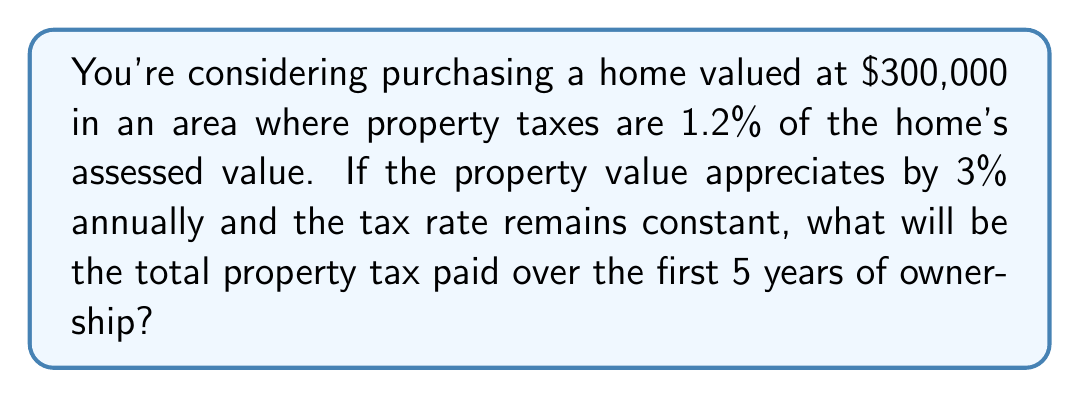Provide a solution to this math problem. Let's approach this step-by-step:

1) First, we need to calculate the property value for each year:
   Year 0 (purchase): $300,000
   Year 1: $300,000 * 1.03 = $309,000
   Year 2: $309,000 * 1.03 = $318,270
   Year 3: $318,270 * 1.03 = $327,818.10
   Year 4: $327,818.10 * 1.03 = $337,652.64
   Year 5: $337,652.64 * 1.03 = $347,782.22

2) Now, we calculate the property tax for each year:
   Year 1: $309,000 * 0.012 = $3,708
   Year 2: $318,270 * 0.012 = $3,819.24
   Year 3: $327,818.10 * 0.012 = $3,933.82
   Year 4: $337,652.64 * 0.012 = $4,051.83
   Year 5: $347,782.22 * 0.012 = $4,173.39

3) Sum up the taxes for all 5 years:
   $$\sum_{i=1}^{5} \text{Tax}_i = 3,708 + 3,819.24 + 3,933.82 + 4,051.83 + 4,173.39$$

4) Calculate the total:
   $$\text{Total Tax} = $19,686.28$$
Answer: $19,686.28 